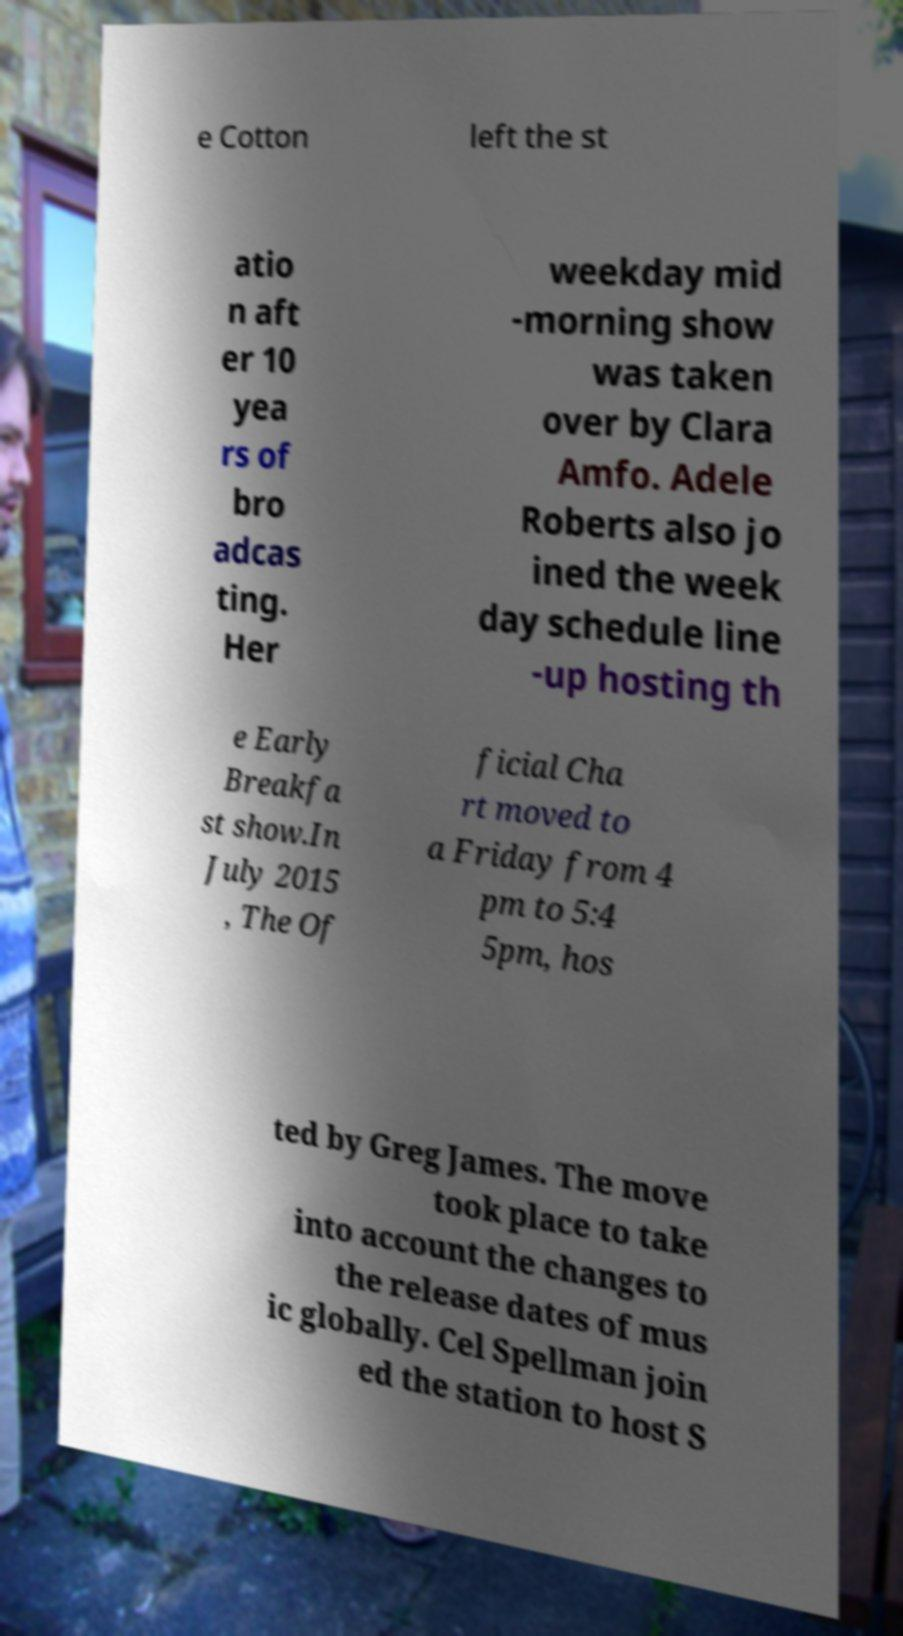Could you assist in decoding the text presented in this image and type it out clearly? e Cotton left the st atio n aft er 10 yea rs of bro adcas ting. Her weekday mid -morning show was taken over by Clara Amfo. Adele Roberts also jo ined the week day schedule line -up hosting th e Early Breakfa st show.In July 2015 , The Of ficial Cha rt moved to a Friday from 4 pm to 5:4 5pm, hos ted by Greg James. The move took place to take into account the changes to the release dates of mus ic globally. Cel Spellman join ed the station to host S 